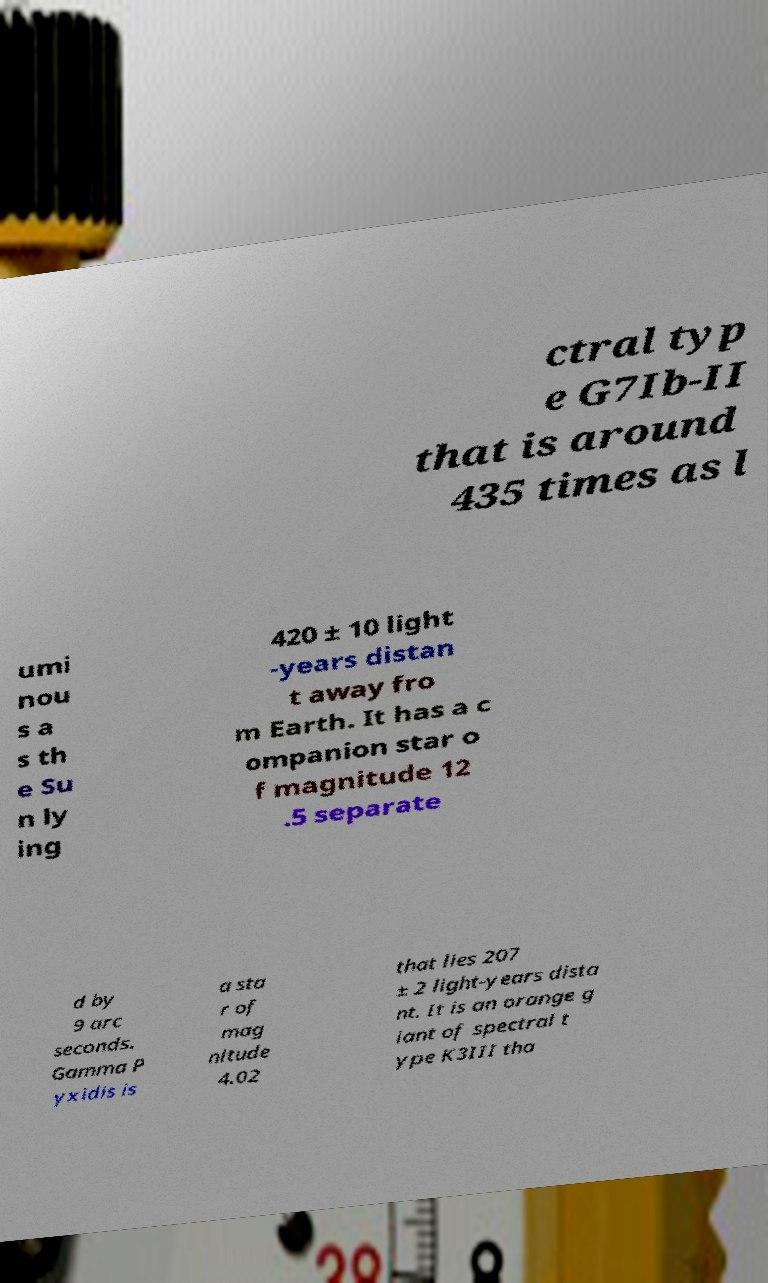I need the written content from this picture converted into text. Can you do that? ctral typ e G7Ib-II that is around 435 times as l umi nou s a s th e Su n ly ing 420 ± 10 light -years distan t away fro m Earth. It has a c ompanion star o f magnitude 12 .5 separate d by 9 arc seconds. Gamma P yxidis is a sta r of mag nitude 4.02 that lies 207 ± 2 light-years dista nt. It is an orange g iant of spectral t ype K3III tha 